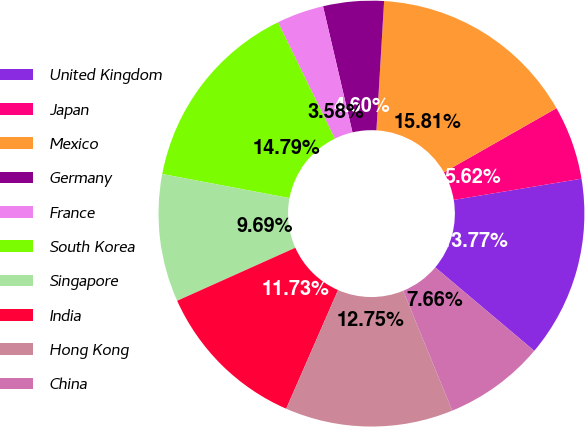Convert chart. <chart><loc_0><loc_0><loc_500><loc_500><pie_chart><fcel>United Kingdom<fcel>Japan<fcel>Mexico<fcel>Germany<fcel>France<fcel>South Korea<fcel>Singapore<fcel>India<fcel>Hong Kong<fcel>China<nl><fcel>13.77%<fcel>5.62%<fcel>15.81%<fcel>4.6%<fcel>3.58%<fcel>14.79%<fcel>9.69%<fcel>11.73%<fcel>12.75%<fcel>7.66%<nl></chart> 